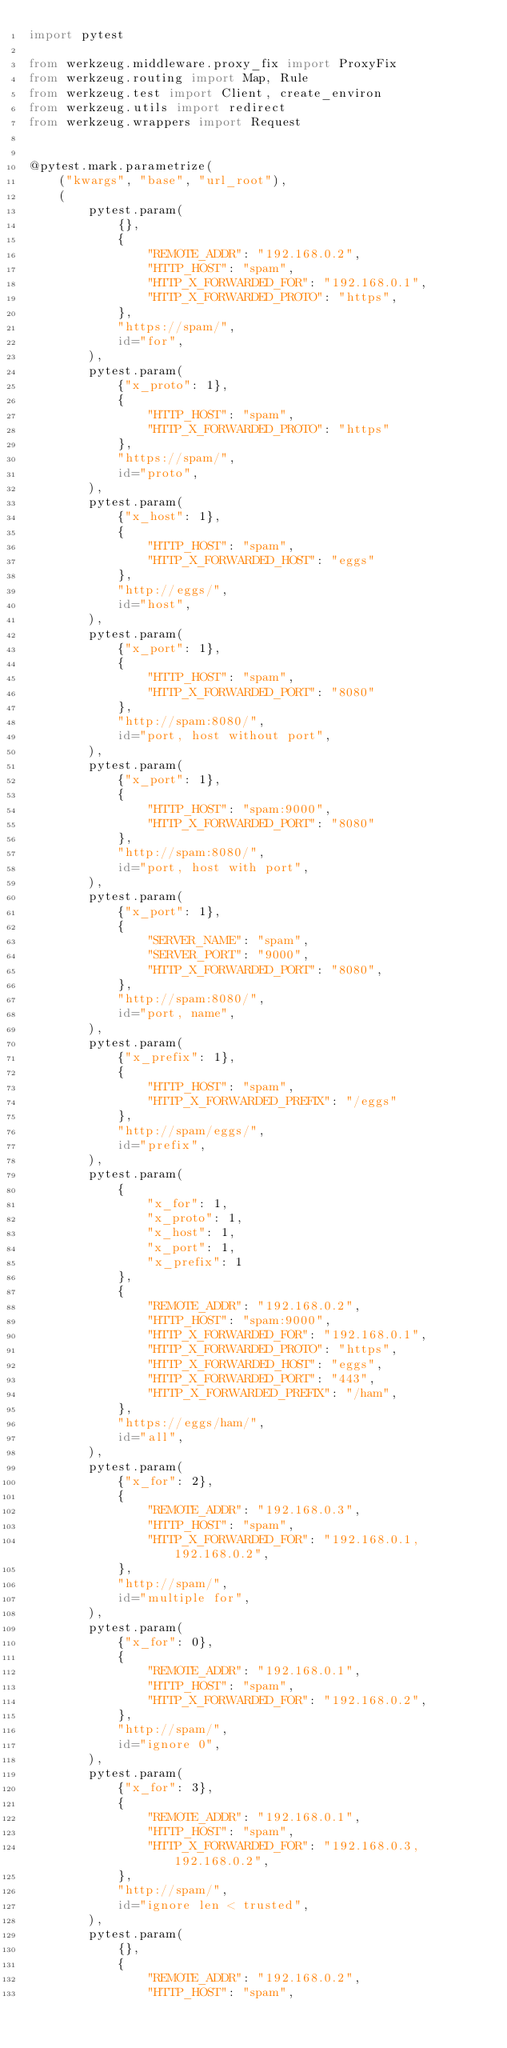<code> <loc_0><loc_0><loc_500><loc_500><_Python_>import pytest

from werkzeug.middleware.proxy_fix import ProxyFix
from werkzeug.routing import Map, Rule
from werkzeug.test import Client, create_environ
from werkzeug.utils import redirect
from werkzeug.wrappers import Request


@pytest.mark.parametrize(
    ("kwargs", "base", "url_root"),
    (
        pytest.param(
            {},
            {
                "REMOTE_ADDR": "192.168.0.2",
                "HTTP_HOST": "spam",
                "HTTP_X_FORWARDED_FOR": "192.168.0.1",
                "HTTP_X_FORWARDED_PROTO": "https",
            },
            "https://spam/",
            id="for",
        ),
        pytest.param(
            {"x_proto": 1},
            {
                "HTTP_HOST": "spam",
                "HTTP_X_FORWARDED_PROTO": "https"
            },
            "https://spam/",
            id="proto",
        ),
        pytest.param(
            {"x_host": 1},
            {
                "HTTP_HOST": "spam",
                "HTTP_X_FORWARDED_HOST": "eggs"
            },
            "http://eggs/",
            id="host",
        ),
        pytest.param(
            {"x_port": 1},
            {
                "HTTP_HOST": "spam",
                "HTTP_X_FORWARDED_PORT": "8080"
            },
            "http://spam:8080/",
            id="port, host without port",
        ),
        pytest.param(
            {"x_port": 1},
            {
                "HTTP_HOST": "spam:9000",
                "HTTP_X_FORWARDED_PORT": "8080"
            },
            "http://spam:8080/",
            id="port, host with port",
        ),
        pytest.param(
            {"x_port": 1},
            {
                "SERVER_NAME": "spam",
                "SERVER_PORT": "9000",
                "HTTP_X_FORWARDED_PORT": "8080",
            },
            "http://spam:8080/",
            id="port, name",
        ),
        pytest.param(
            {"x_prefix": 1},
            {
                "HTTP_HOST": "spam",
                "HTTP_X_FORWARDED_PREFIX": "/eggs"
            },
            "http://spam/eggs/",
            id="prefix",
        ),
        pytest.param(
            {
                "x_for": 1,
                "x_proto": 1,
                "x_host": 1,
                "x_port": 1,
                "x_prefix": 1
            },
            {
                "REMOTE_ADDR": "192.168.0.2",
                "HTTP_HOST": "spam:9000",
                "HTTP_X_FORWARDED_FOR": "192.168.0.1",
                "HTTP_X_FORWARDED_PROTO": "https",
                "HTTP_X_FORWARDED_HOST": "eggs",
                "HTTP_X_FORWARDED_PORT": "443",
                "HTTP_X_FORWARDED_PREFIX": "/ham",
            },
            "https://eggs/ham/",
            id="all",
        ),
        pytest.param(
            {"x_for": 2},
            {
                "REMOTE_ADDR": "192.168.0.3",
                "HTTP_HOST": "spam",
                "HTTP_X_FORWARDED_FOR": "192.168.0.1, 192.168.0.2",
            },
            "http://spam/",
            id="multiple for",
        ),
        pytest.param(
            {"x_for": 0},
            {
                "REMOTE_ADDR": "192.168.0.1",
                "HTTP_HOST": "spam",
                "HTTP_X_FORWARDED_FOR": "192.168.0.2",
            },
            "http://spam/",
            id="ignore 0",
        ),
        pytest.param(
            {"x_for": 3},
            {
                "REMOTE_ADDR": "192.168.0.1",
                "HTTP_HOST": "spam",
                "HTTP_X_FORWARDED_FOR": "192.168.0.3, 192.168.0.2",
            },
            "http://spam/",
            id="ignore len < trusted",
        ),
        pytest.param(
            {},
            {
                "REMOTE_ADDR": "192.168.0.2",
                "HTTP_HOST": "spam",</code> 